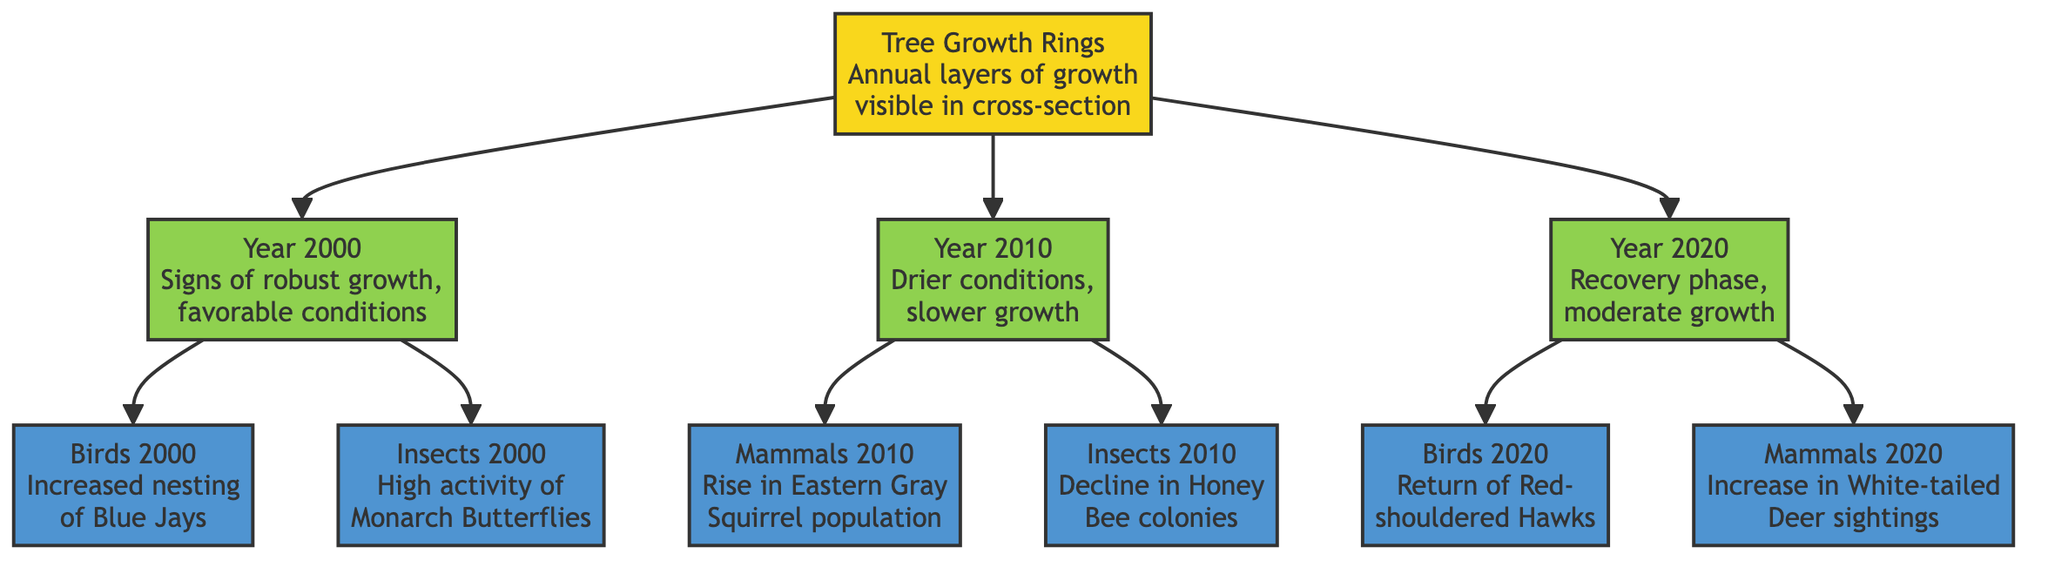What year shows signs of robust growth in tree growth rings? From the diagram, "Year 2000" indicates "Signs of robust growth, favorable conditions". Therefore, the year that shows these signs is 2000.
Answer: 2000 How many wildlife activities are associated with the year 2010? The diagram shows two wildlife activities linked to the year 2010: the rise in Eastern Gray Squirrel population and the decline in Honey Bee colonies. Thus, there are two activities associated with this year.
Answer: 2 What type of bird returned in 2020? The diagram states that "Birds 2020" is about the "Return of Red-shouldered Hawks". Therefore, the type of bird that returned in this year is the Red-shouldered Hawk.
Answer: Red-shouldered Hawk What wildlife activity corresponds with the year 2000? In the year 2000, the diagram indicates increased nesting of Blue Jays and high activity of Monarch Butterflies. Both of these represent wildlife activities linked to that year.
Answer: Increased nesting of Blue Jays, High activity of Monarch Butterflies Which year experienced drier conditions leading to slower growth? The diagram explicitly notes that "Year 2010" faced "Drier conditions, slower growth". Thus, the year that experienced these conditions is 2010.
Answer: 2010 What is the relationship between the year 2020 and mammal sightings? The diagram shows that in "Year 2020" there was an "Increase in White-tailed Deer sightings", which indicates a positive relationship between the year 2020 and mammal activity.
Answer: Increase in White-tailed Deer sightings Which insect showed high activity in the year 2000? According to the diagram, the insect mentioned for the year 2000 is the "Monarch Butterflies", indicating their high activity during that year.
Answer: Monarch Butterflies Identify the wildlife activity linked to the core with the year 2020. The core connects to "Ring 3", which corresponds to the year 2020. The wildlife activities linked to this year include "Birds 2020" for Red-shouldered Hawks and "Mammals 2020" for the increase in White-tailed Deer sightings. Therefore, both are linked to the core in 2020.
Answer: Birds 2020, Mammals 2020 